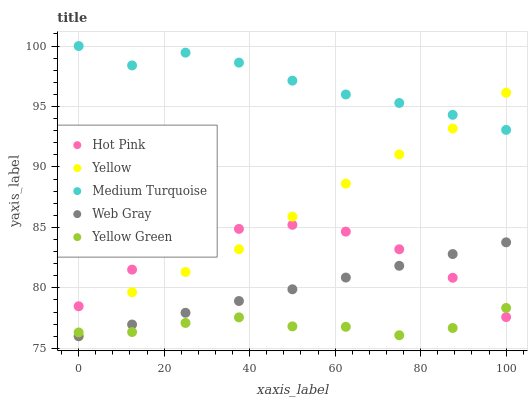Does Yellow Green have the minimum area under the curve?
Answer yes or no. Yes. Does Medium Turquoise have the maximum area under the curve?
Answer yes or no. Yes. Does Web Gray have the minimum area under the curve?
Answer yes or no. No. Does Web Gray have the maximum area under the curve?
Answer yes or no. No. Is Web Gray the smoothest?
Answer yes or no. Yes. Is Medium Turquoise the roughest?
Answer yes or no. Yes. Is Medium Turquoise the smoothest?
Answer yes or no. No. Is Web Gray the roughest?
Answer yes or no. No. Does Web Gray have the lowest value?
Answer yes or no. Yes. Does Medium Turquoise have the lowest value?
Answer yes or no. No. Does Medium Turquoise have the highest value?
Answer yes or no. Yes. Does Web Gray have the highest value?
Answer yes or no. No. Is Web Gray less than Medium Turquoise?
Answer yes or no. Yes. Is Medium Turquoise greater than Hot Pink?
Answer yes or no. Yes. Does Yellow Green intersect Web Gray?
Answer yes or no. Yes. Is Yellow Green less than Web Gray?
Answer yes or no. No. Is Yellow Green greater than Web Gray?
Answer yes or no. No. Does Web Gray intersect Medium Turquoise?
Answer yes or no. No. 